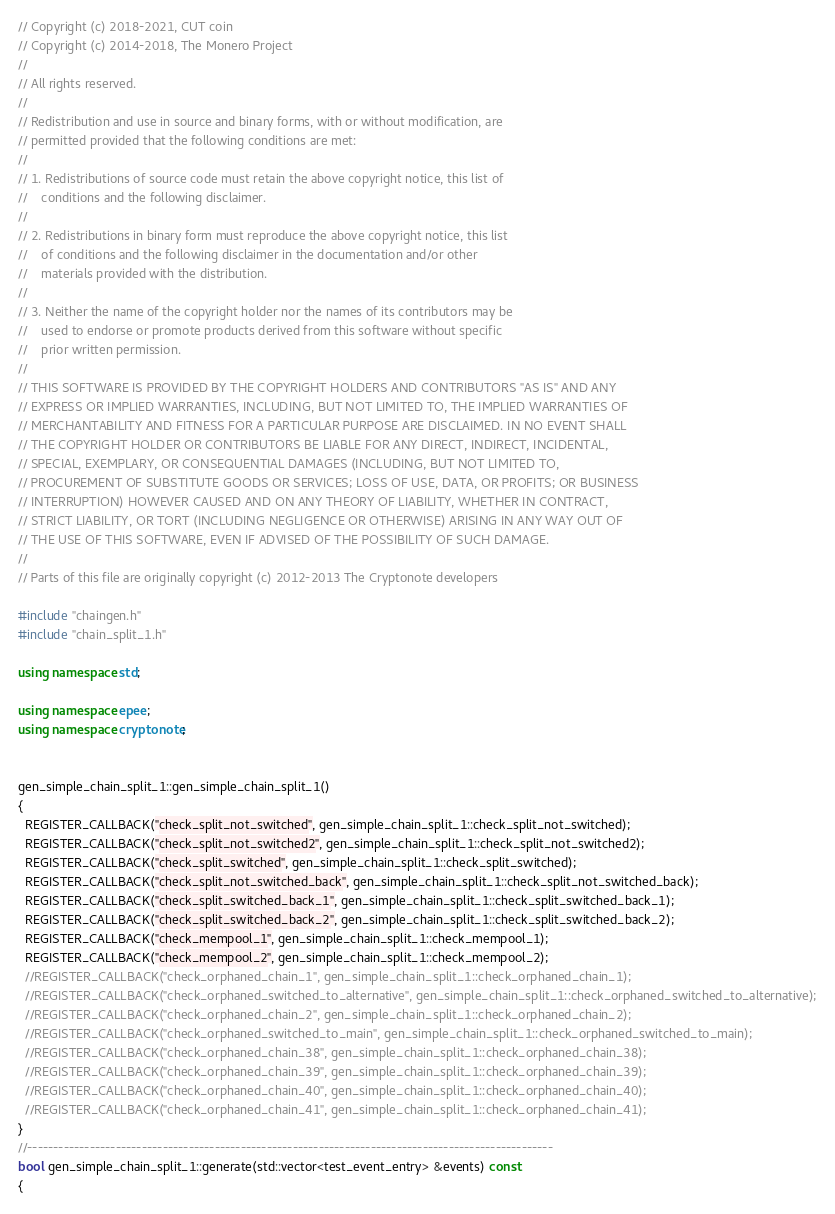<code> <loc_0><loc_0><loc_500><loc_500><_C++_>// Copyright (c) 2018-2021, CUT coin
// Copyright (c) 2014-2018, The Monero Project
// 
// All rights reserved.
// 
// Redistribution and use in source and binary forms, with or without modification, are
// permitted provided that the following conditions are met:
// 
// 1. Redistributions of source code must retain the above copyright notice, this list of
//    conditions and the following disclaimer.
// 
// 2. Redistributions in binary form must reproduce the above copyright notice, this list
//    of conditions and the following disclaimer in the documentation and/or other
//    materials provided with the distribution.
// 
// 3. Neither the name of the copyright holder nor the names of its contributors may be
//    used to endorse or promote products derived from this software without specific
//    prior written permission.
// 
// THIS SOFTWARE IS PROVIDED BY THE COPYRIGHT HOLDERS AND CONTRIBUTORS "AS IS" AND ANY
// EXPRESS OR IMPLIED WARRANTIES, INCLUDING, BUT NOT LIMITED TO, THE IMPLIED WARRANTIES OF
// MERCHANTABILITY AND FITNESS FOR A PARTICULAR PURPOSE ARE DISCLAIMED. IN NO EVENT SHALL
// THE COPYRIGHT HOLDER OR CONTRIBUTORS BE LIABLE FOR ANY DIRECT, INDIRECT, INCIDENTAL,
// SPECIAL, EXEMPLARY, OR CONSEQUENTIAL DAMAGES (INCLUDING, BUT NOT LIMITED TO,
// PROCUREMENT OF SUBSTITUTE GOODS OR SERVICES; LOSS OF USE, DATA, OR PROFITS; OR BUSINESS
// INTERRUPTION) HOWEVER CAUSED AND ON ANY THEORY OF LIABILITY, WHETHER IN CONTRACT,
// STRICT LIABILITY, OR TORT (INCLUDING NEGLIGENCE OR OTHERWISE) ARISING IN ANY WAY OUT OF
// THE USE OF THIS SOFTWARE, EVEN IF ADVISED OF THE POSSIBILITY OF SUCH DAMAGE.
// 
// Parts of this file are originally copyright (c) 2012-2013 The Cryptonote developers

#include "chaingen.h"
#include "chain_split_1.h"

using namespace std;

using namespace epee;
using namespace cryptonote;


gen_simple_chain_split_1::gen_simple_chain_split_1()
{
  REGISTER_CALLBACK("check_split_not_switched", gen_simple_chain_split_1::check_split_not_switched);
  REGISTER_CALLBACK("check_split_not_switched2", gen_simple_chain_split_1::check_split_not_switched2);
  REGISTER_CALLBACK("check_split_switched", gen_simple_chain_split_1::check_split_switched);
  REGISTER_CALLBACK("check_split_not_switched_back", gen_simple_chain_split_1::check_split_not_switched_back);
  REGISTER_CALLBACK("check_split_switched_back_1", gen_simple_chain_split_1::check_split_switched_back_1);
  REGISTER_CALLBACK("check_split_switched_back_2", gen_simple_chain_split_1::check_split_switched_back_2);
  REGISTER_CALLBACK("check_mempool_1", gen_simple_chain_split_1::check_mempool_1);
  REGISTER_CALLBACK("check_mempool_2", gen_simple_chain_split_1::check_mempool_2);
  //REGISTER_CALLBACK("check_orphaned_chain_1", gen_simple_chain_split_1::check_orphaned_chain_1);
  //REGISTER_CALLBACK("check_orphaned_switched_to_alternative", gen_simple_chain_split_1::check_orphaned_switched_to_alternative);
  //REGISTER_CALLBACK("check_orphaned_chain_2", gen_simple_chain_split_1::check_orphaned_chain_2);
  //REGISTER_CALLBACK("check_orphaned_switched_to_main", gen_simple_chain_split_1::check_orphaned_switched_to_main);
  //REGISTER_CALLBACK("check_orphaned_chain_38", gen_simple_chain_split_1::check_orphaned_chain_38);
  //REGISTER_CALLBACK("check_orphaned_chain_39", gen_simple_chain_split_1::check_orphaned_chain_39);
  //REGISTER_CALLBACK("check_orphaned_chain_40", gen_simple_chain_split_1::check_orphaned_chain_40);
  //REGISTER_CALLBACK("check_orphaned_chain_41", gen_simple_chain_split_1::check_orphaned_chain_41);
}
//-----------------------------------------------------------------------------------------------------
bool gen_simple_chain_split_1::generate(std::vector<test_event_entry> &events) const
{</code> 